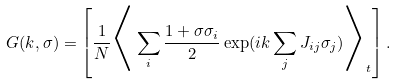Convert formula to latex. <formula><loc_0><loc_0><loc_500><loc_500>G ( k , \sigma ) = \left [ \frac { 1 } { N } \Big < \sum _ { i } \frac { 1 + \sigma \sigma _ { i } } { 2 } \exp ( i k \sum _ { j } J _ { i j } \sigma _ { j } ) \Big > _ { t } \right ] .</formula> 